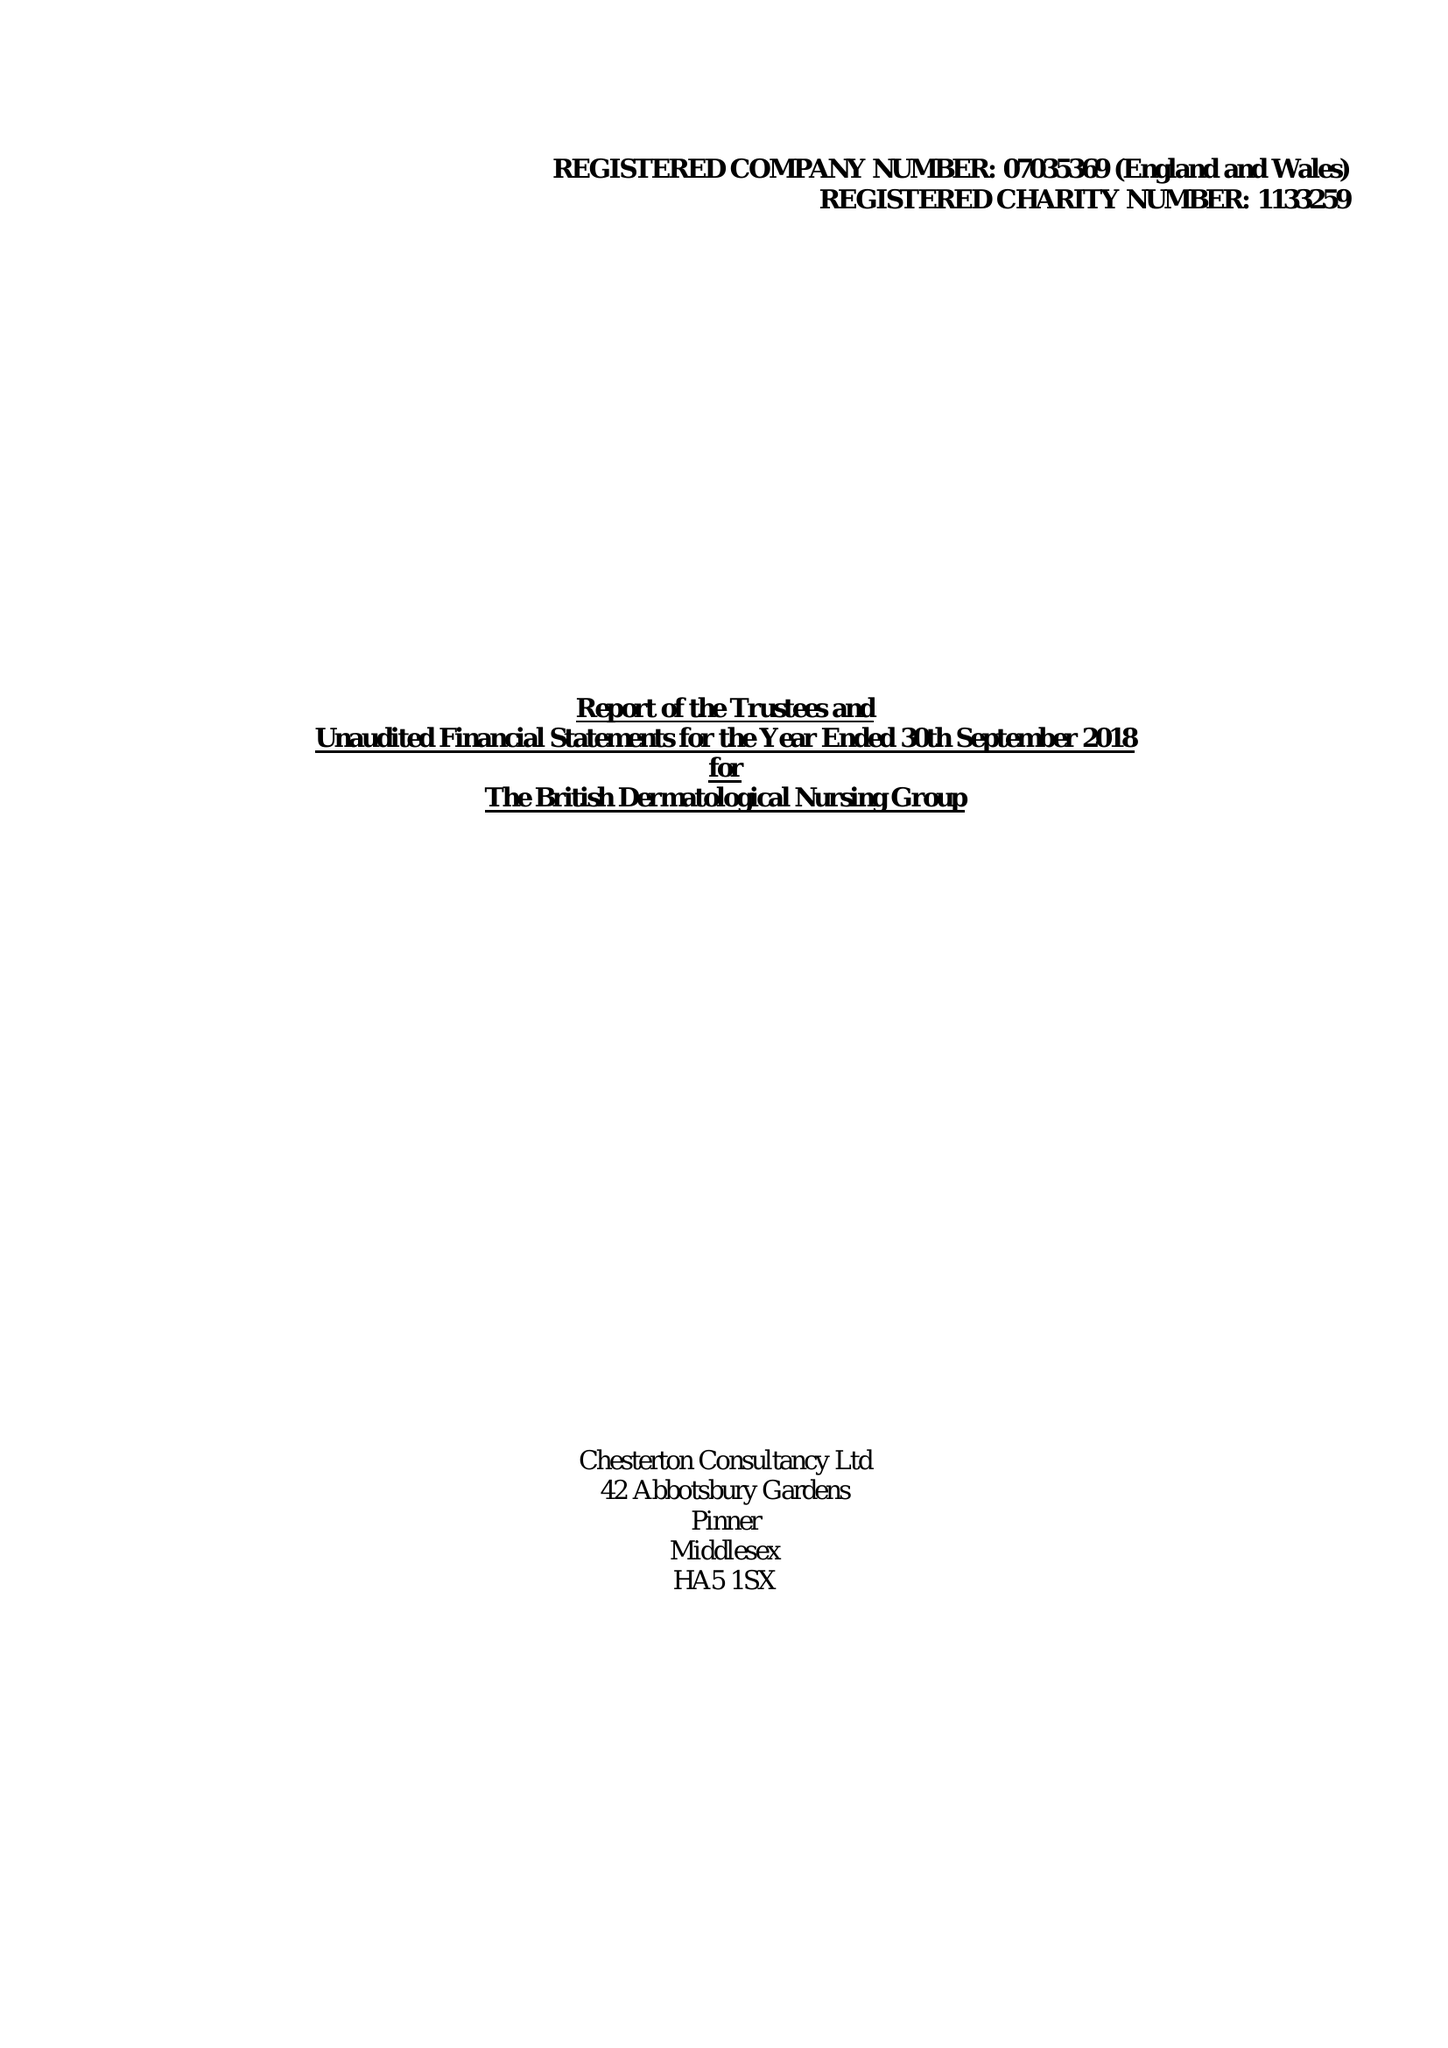What is the value for the income_annually_in_british_pounds?
Answer the question using a single word or phrase. 412400.00 